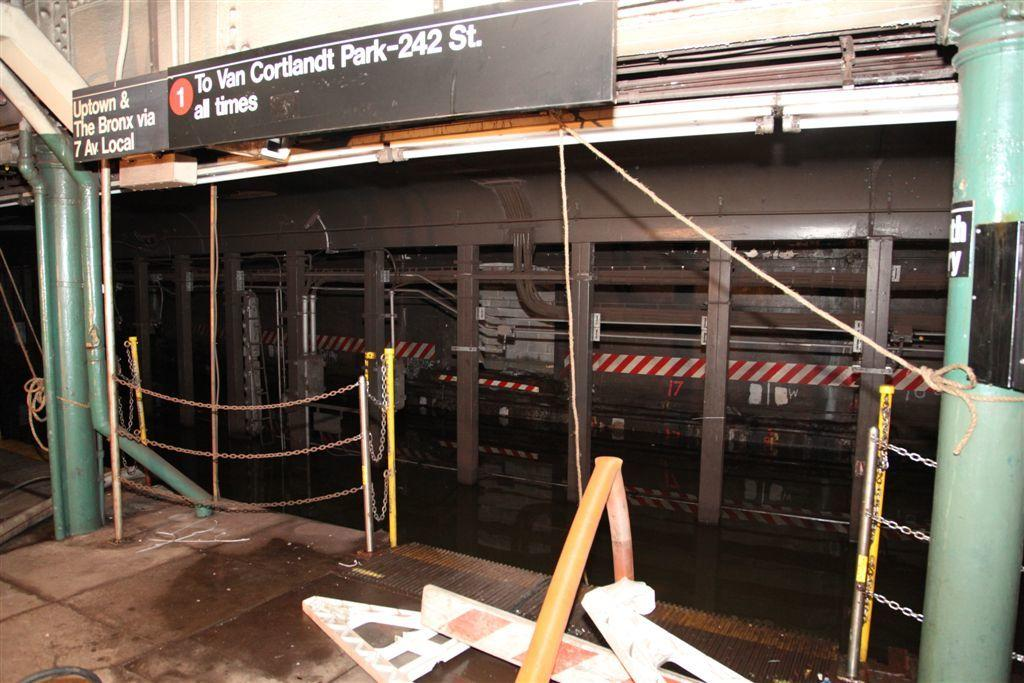What is the main subject of the image? The main subject of the image is a building. What type of gold drink can be seen being served in the building? There is no mention of a gold drink or any drinks in the image, as the image only features a building. 